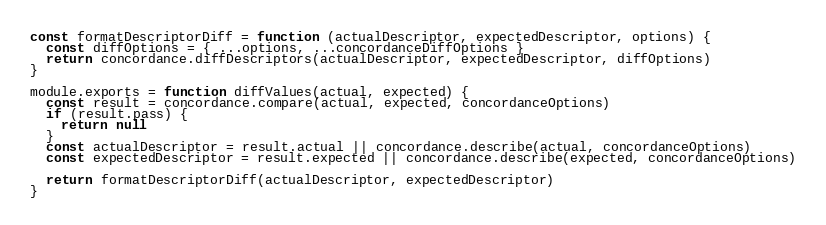<code> <loc_0><loc_0><loc_500><loc_500><_JavaScript_>
const formatDescriptorDiff = function (actualDescriptor, expectedDescriptor, options) {
  const diffOptions = { ...options, ...concordanceDiffOptions }
  return concordance.diffDescriptors(actualDescriptor, expectedDescriptor, diffOptions)
}

module.exports = function diffValues(actual, expected) {
  const result = concordance.compare(actual, expected, concordanceOptions)
  if (result.pass) {
    return null
  }
  const actualDescriptor = result.actual || concordance.describe(actual, concordanceOptions)
  const expectedDescriptor = result.expected || concordance.describe(expected, concordanceOptions)

  return formatDescriptorDiff(actualDescriptor, expectedDescriptor)
}
</code> 